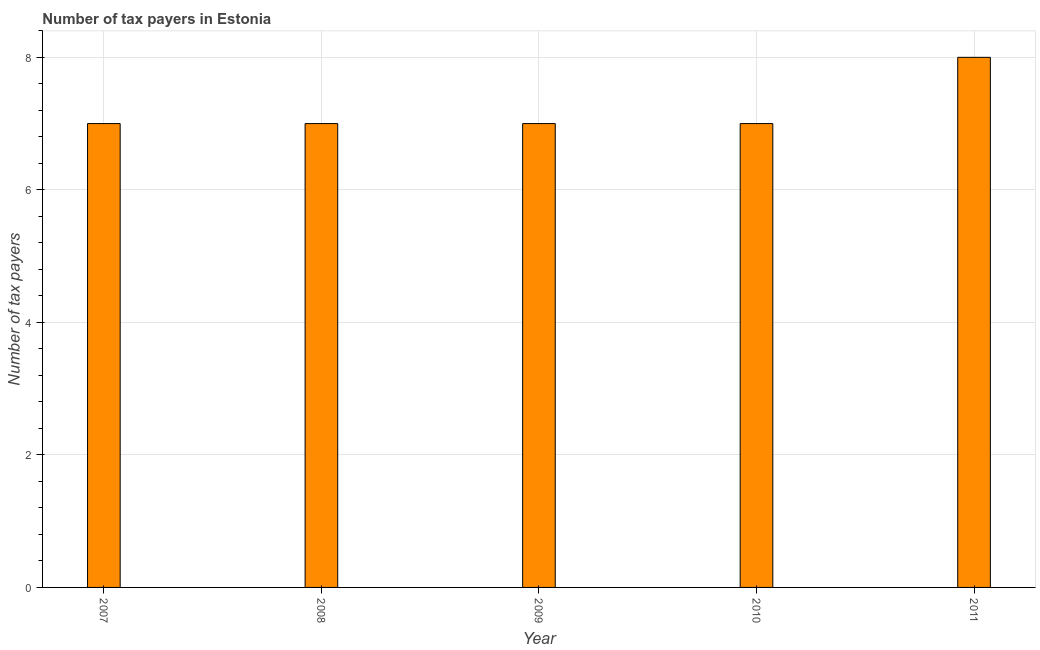What is the title of the graph?
Provide a succinct answer. Number of tax payers in Estonia. What is the label or title of the X-axis?
Offer a very short reply. Year. What is the label or title of the Y-axis?
Your response must be concise. Number of tax payers. In which year was the number of tax payers maximum?
Provide a short and direct response. 2011. In which year was the number of tax payers minimum?
Your response must be concise. 2007. What is the sum of the number of tax payers?
Ensure brevity in your answer.  36. What is the difference between the number of tax payers in 2008 and 2011?
Give a very brief answer. -1. What is the average number of tax payers per year?
Provide a short and direct response. 7. Do a majority of the years between 2008 and 2009 (inclusive) have number of tax payers greater than 0.4 ?
Offer a very short reply. Yes. What is the ratio of the number of tax payers in 2008 to that in 2010?
Provide a short and direct response. 1. Is the number of tax payers in 2008 less than that in 2009?
Provide a short and direct response. No. Is the difference between the number of tax payers in 2008 and 2010 greater than the difference between any two years?
Your response must be concise. No. In how many years, is the number of tax payers greater than the average number of tax payers taken over all years?
Keep it short and to the point. 1. Are the values on the major ticks of Y-axis written in scientific E-notation?
Ensure brevity in your answer.  No. What is the Number of tax payers of 2007?
Keep it short and to the point. 7. What is the Number of tax payers of 2008?
Your answer should be very brief. 7. What is the Number of tax payers of 2010?
Give a very brief answer. 7. What is the difference between the Number of tax payers in 2007 and 2008?
Ensure brevity in your answer.  0. What is the difference between the Number of tax payers in 2007 and 2009?
Provide a short and direct response. 0. What is the difference between the Number of tax payers in 2007 and 2011?
Your response must be concise. -1. What is the difference between the Number of tax payers in 2008 and 2010?
Offer a very short reply. 0. What is the difference between the Number of tax payers in 2010 and 2011?
Make the answer very short. -1. What is the ratio of the Number of tax payers in 2007 to that in 2009?
Your answer should be very brief. 1. What is the ratio of the Number of tax payers in 2007 to that in 2010?
Ensure brevity in your answer.  1. What is the ratio of the Number of tax payers in 2008 to that in 2009?
Offer a terse response. 1. What is the ratio of the Number of tax payers in 2008 to that in 2010?
Your response must be concise. 1. What is the ratio of the Number of tax payers in 2009 to that in 2010?
Provide a succinct answer. 1. 